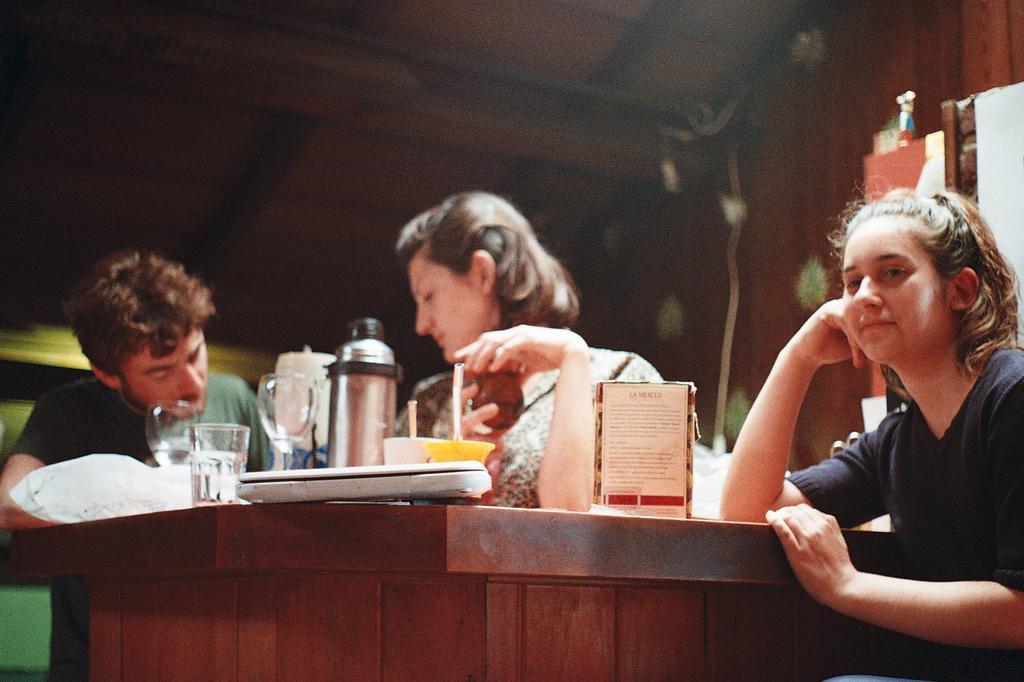Please provide a concise description of this image. There are three persons in this image. The girl at the right side is smiling and is leaning on the table. In the center woman is looking at the left side, the boy in the green shirt is doing some work. On the table there are glasses, jar. In the background there is a wall. 